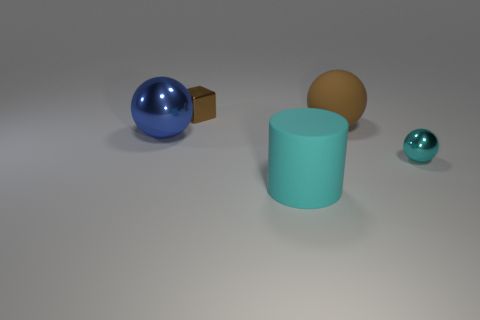Add 4 red matte cylinders. How many objects exist? 9 Subtract all spheres. How many objects are left? 2 Subtract 1 blue balls. How many objects are left? 4 Subtract all tiny gray metallic spheres. Subtract all blue metal balls. How many objects are left? 4 Add 2 big brown rubber balls. How many big brown rubber balls are left? 3 Add 1 tiny brown cubes. How many tiny brown cubes exist? 2 